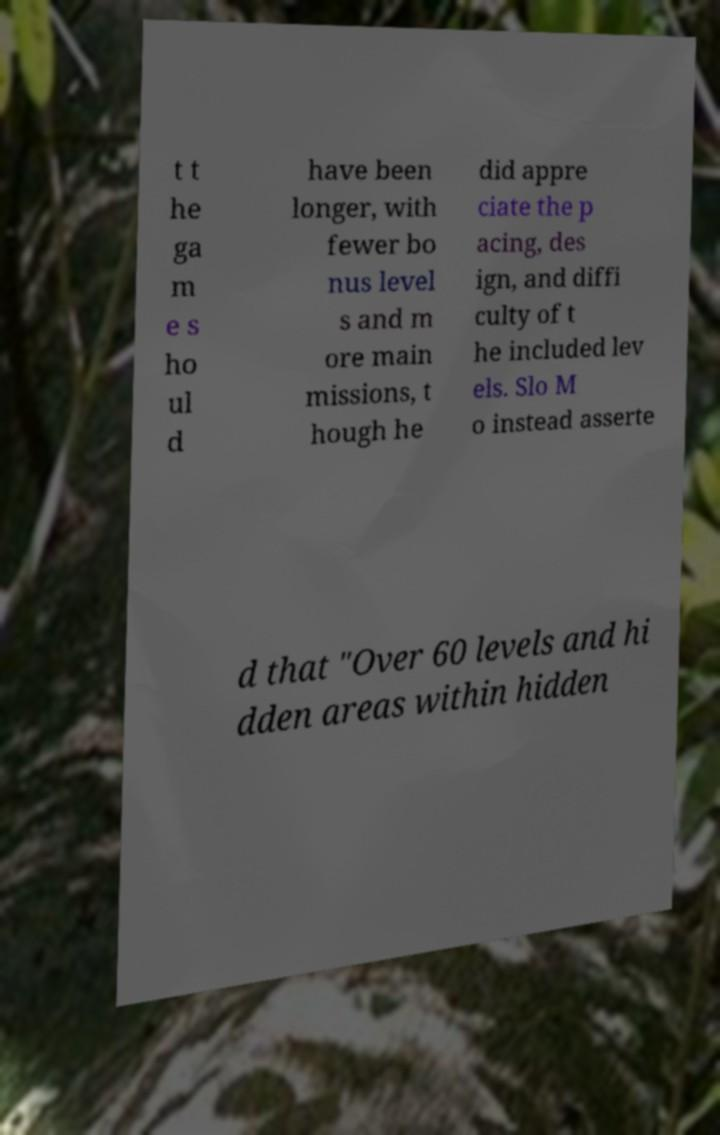Can you accurately transcribe the text from the provided image for me? t t he ga m e s ho ul d have been longer, with fewer bo nus level s and m ore main missions, t hough he did appre ciate the p acing, des ign, and diffi culty of t he included lev els. Slo M o instead asserte d that "Over 60 levels and hi dden areas within hidden 